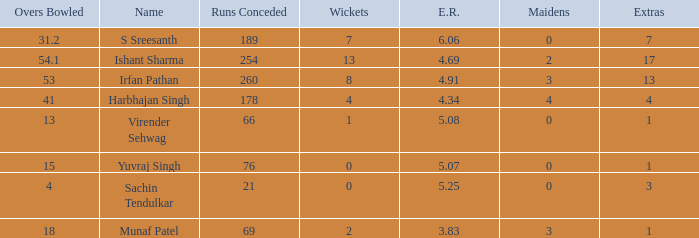Would you be able to parse every entry in this table? {'header': ['Overs Bowled', 'Name', 'Runs Conceded', 'Wickets', 'E.R.', 'Maidens', 'Extras'], 'rows': [['31.2', 'S Sreesanth', '189', '7', '6.06', '0', '7'], ['54.1', 'Ishant Sharma', '254', '13', '4.69', '2', '17'], ['53', 'Irfan Pathan', '260', '8', '4.91', '3', '13'], ['41', 'Harbhajan Singh', '178', '4', '4.34', '4', '4'], ['13', 'Virender Sehwag', '66', '1', '5.08', '0', '1'], ['15', 'Yuvraj Singh', '76', '0', '5.07', '0', '1'], ['4', 'Sachin Tendulkar', '21', '0', '5.25', '0', '3'], ['18', 'Munaf Patel', '69', '2', '3.83', '3', '1']]} Name the runs conceded where overs bowled is 53 1.0. 